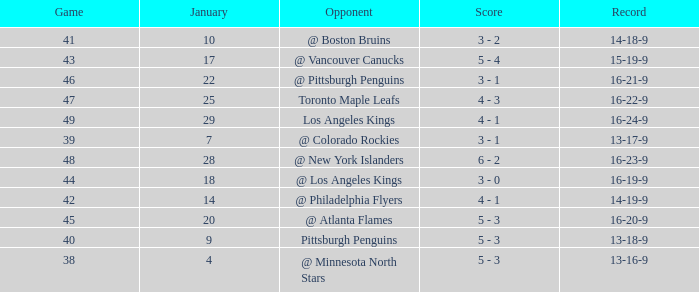What was the record after the game before Jan 7? 13-16-9. 